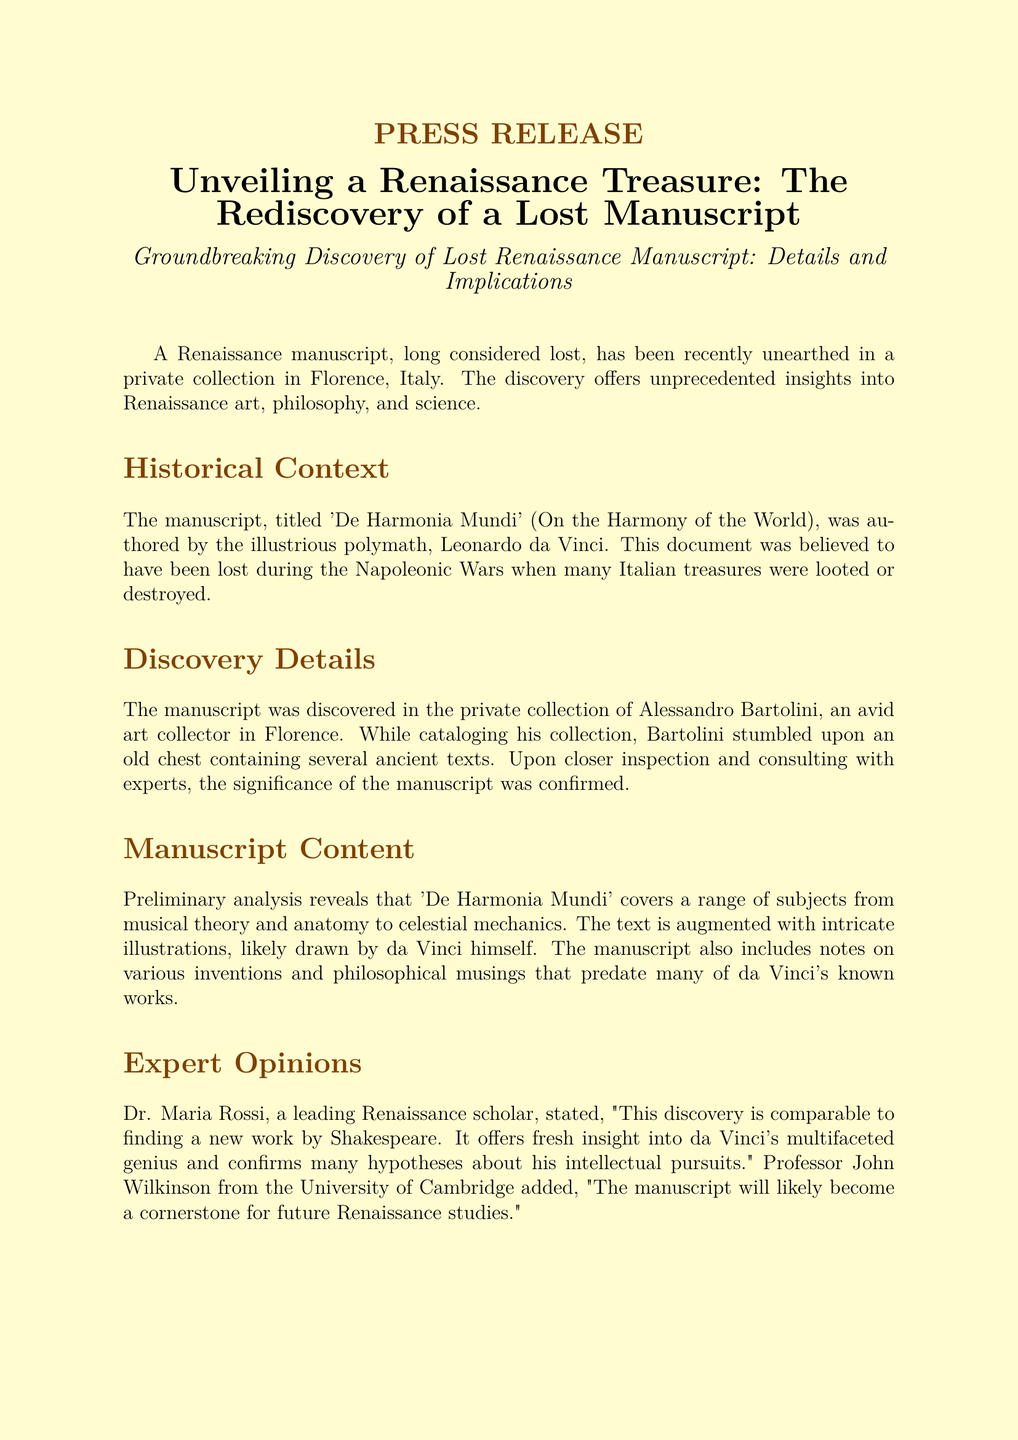What is the title of the rediscovered manuscript? The title of the manuscript mentioned in the document is 'De Harmonia Mundi'.
Answer: 'De Harmonia Mundi' Who authored the manuscript? The manuscript was authored by Leonardo da Vinci, as stated in the document.
Answer: Leonardo da Vinci Where was the manuscript found? The document specifies that the manuscript was discovered in Florence, Italy.
Answer: Florence, Italy What was the name of the collector who found the manuscript? The collector who found the manuscript is named Alessandro Bartolini.
Answer: Alessandro Bartolini What significant historical event contributed to the manuscript's loss? The manuscript was believed to have been lost during the Napoleonic Wars, as per the document.
Answer: Napoleonic Wars How does Dr. Maria Rossi describe the discovery? Dr. Maria Rossi compares the discovery to finding a new work by Shakespeare, indicating its significance.
Answer: Comparable to finding a new work by Shakespeare What future plan is mentioned for the manuscript? The manuscript is set to undergo extensive conservation efforts as mentioned in the document.
Answer: Conservation efforts Which gallery will exhibit the manuscript after conservation? The Uffizi Gallery in Florence is where the manuscript will be exhibited.
Answer: Uffizi Gallery What type of analysis has been conducted on the manuscript so far? The document states that a preliminary analysis has been conducted on the manuscript.
Answer: Preliminary analysis 